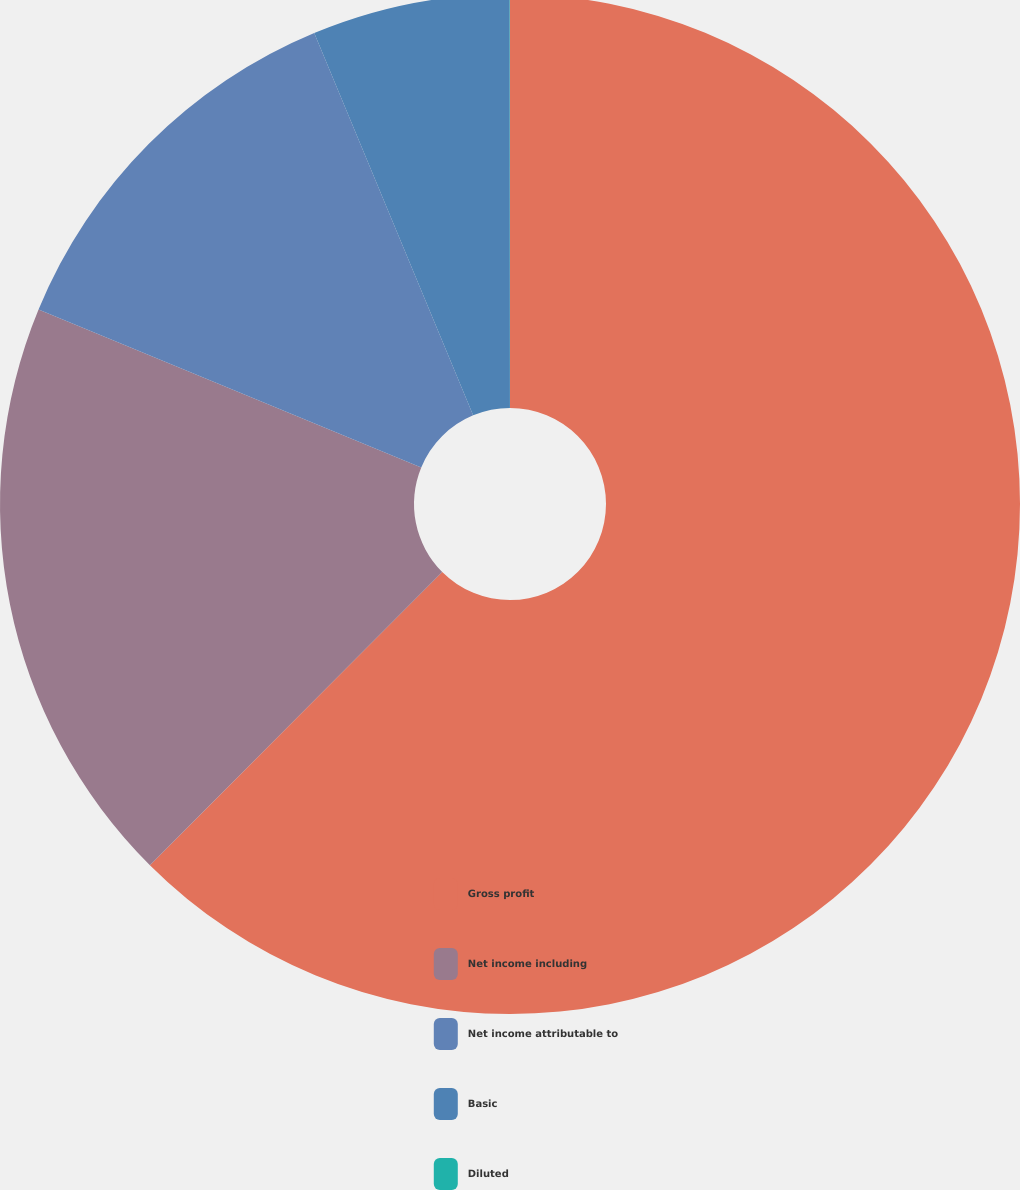Convert chart to OTSL. <chart><loc_0><loc_0><loc_500><loc_500><pie_chart><fcel>Gross profit<fcel>Net income including<fcel>Net income attributable to<fcel>Basic<fcel>Diluted<nl><fcel>62.47%<fcel>18.75%<fcel>12.5%<fcel>6.26%<fcel>0.01%<nl></chart> 